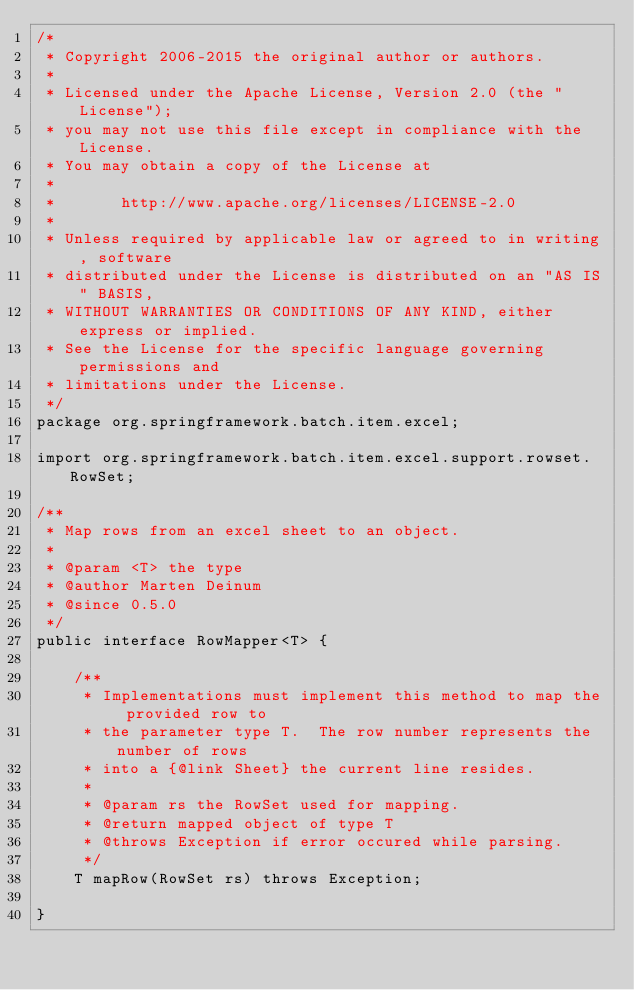Convert code to text. <code><loc_0><loc_0><loc_500><loc_500><_Java_>/*
 * Copyright 2006-2015 the original author or authors.
 *
 * Licensed under the Apache License, Version 2.0 (the "License");
 * you may not use this file except in compliance with the License.
 * You may obtain a copy of the License at
 *
 *       http://www.apache.org/licenses/LICENSE-2.0
 *
 * Unless required by applicable law or agreed to in writing, software
 * distributed under the License is distributed on an "AS IS" BASIS,
 * WITHOUT WARRANTIES OR CONDITIONS OF ANY KIND, either express or implied.
 * See the License for the specific language governing permissions and
 * limitations under the License.
 */
package org.springframework.batch.item.excel;

import org.springframework.batch.item.excel.support.rowset.RowSet;

/**
 * Map rows from an excel sheet to an object.
 *
 * @param <T> the type
 * @author Marten Deinum
 * @since 0.5.0
 */
public interface RowMapper<T> {

    /**
     * Implementations must implement this method to map the provided row to
     * the parameter type T.  The row number represents the number of rows
     * into a {@link Sheet} the current line resides.
     *
     * @param rs the RowSet used for mapping.
     * @return mapped object of type T
     * @throws Exception if error occured while parsing.
     */
    T mapRow(RowSet rs) throws Exception;

}
</code> 